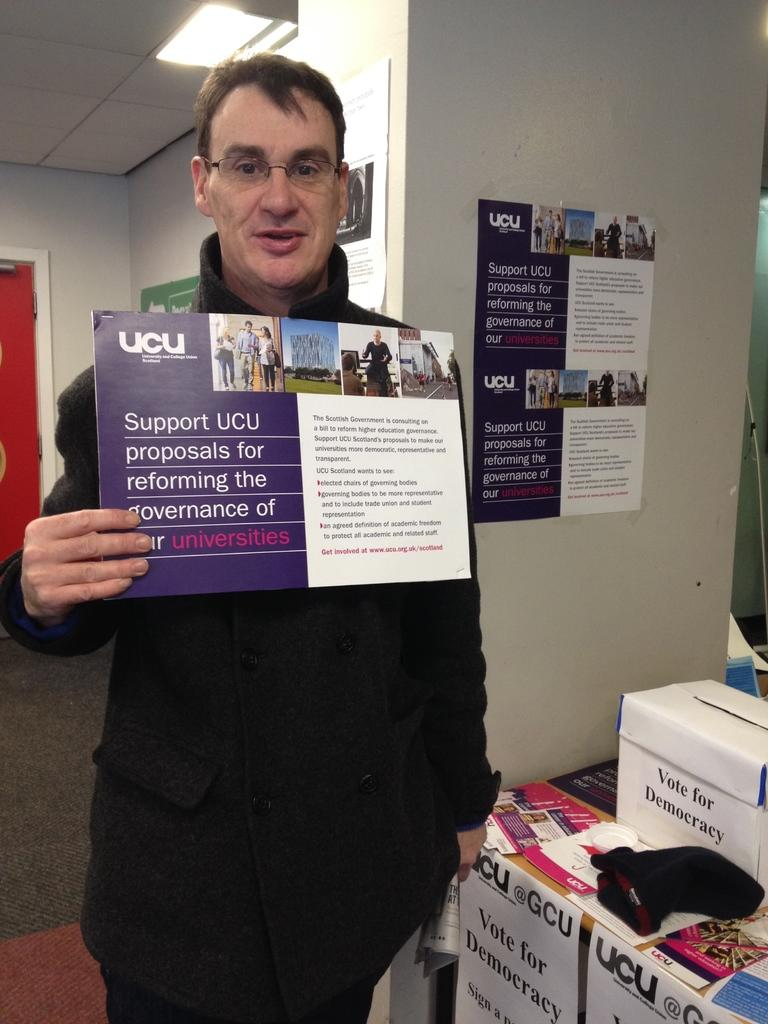Provide a one-sentence caption for the provided image. A man holds stands in an office, holding a sign that supports government reform. 